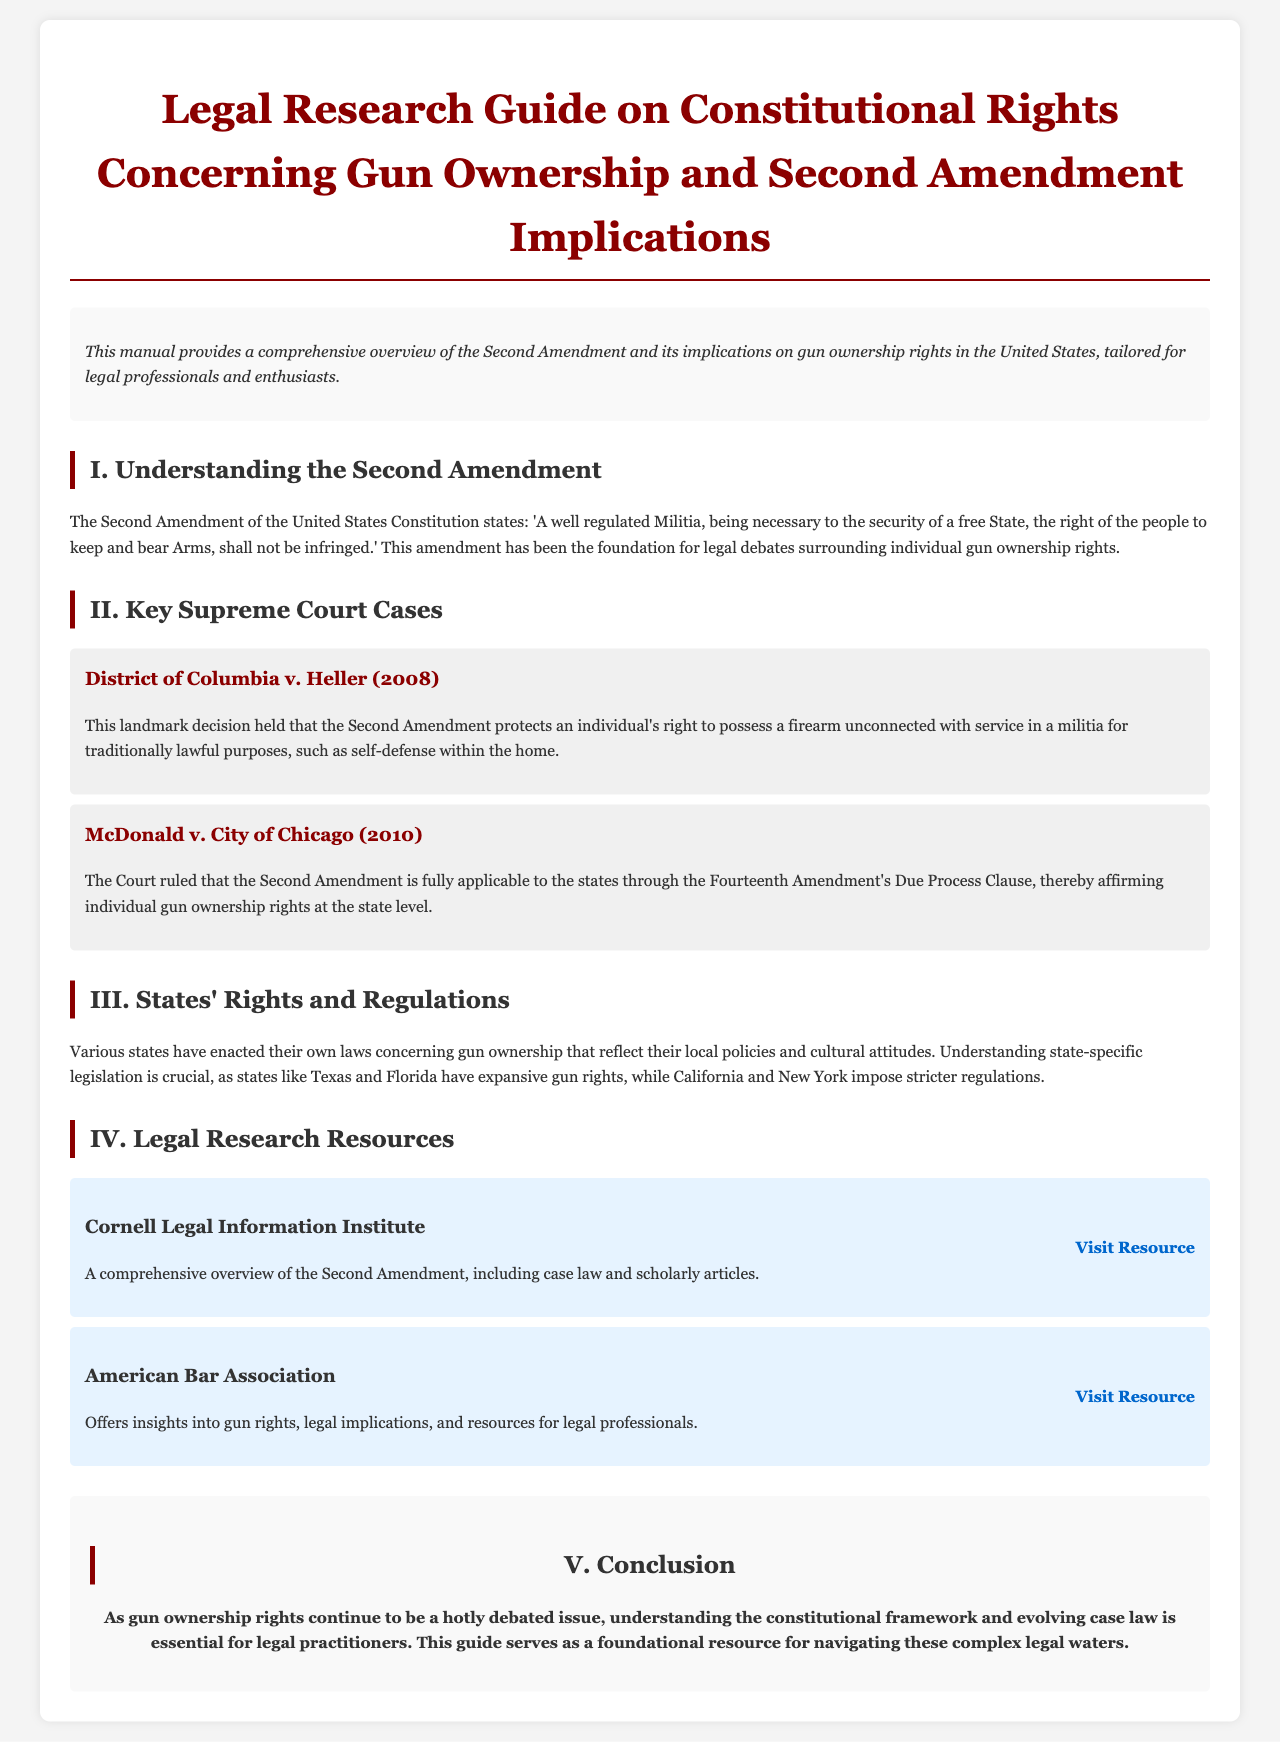What does the Second Amendment state? The Second Amendment text is included in the document, highlighting its core implications regarding gun ownership.
Answer: 'A well regulated Militia, being necessary to the security of a free State, the right of the people to keep and bear Arms, shall not be infringed.' What year was District of Columbia v. Heller decided? The decision date for District of Columbia v. Heller is specified in the document as a key case.
Answer: 2008 What principle did McDonald v. City of Chicago establish? The document outlines the ruling's significance regarding the applicability of the Second Amendment through the Fourteenth Amendment.
Answer: Affirmed individual gun ownership rights at the state level Which organization offers insights into gun rights? The document lists organizations that provide valuable resources and insights into the legal implications of gun rights.
Answer: American Bar Association How many key Supreme Court cases are discussed? The number of cases highlighted in the section about key Supreme Court cases informs about the coverage of the topic.
Answer: Two What is the purpose of this manual? The introductory section describes the aim of the manual in relation to legal professionals and enthusiasts.
Answer: Provides a comprehensive overview of the Second Amendment and its implications Which state is mentioned as having expansive gun rights? The document provides examples of states and their gun ownership policies, particularly highlighting those with more lenient laws.
Answer: Texas What is the final section of the document titled? The conclusion summarizes the content and implications of legal practices concerning gun ownership outlined in the document.
Answer: Conclusion 